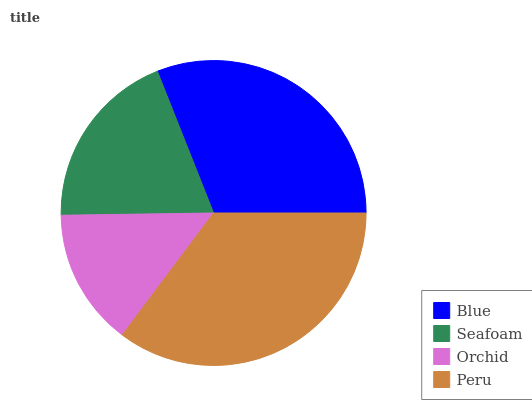Is Orchid the minimum?
Answer yes or no. Yes. Is Peru the maximum?
Answer yes or no. Yes. Is Seafoam the minimum?
Answer yes or no. No. Is Seafoam the maximum?
Answer yes or no. No. Is Blue greater than Seafoam?
Answer yes or no. Yes. Is Seafoam less than Blue?
Answer yes or no. Yes. Is Seafoam greater than Blue?
Answer yes or no. No. Is Blue less than Seafoam?
Answer yes or no. No. Is Blue the high median?
Answer yes or no. Yes. Is Seafoam the low median?
Answer yes or no. Yes. Is Seafoam the high median?
Answer yes or no. No. Is Peru the low median?
Answer yes or no. No. 